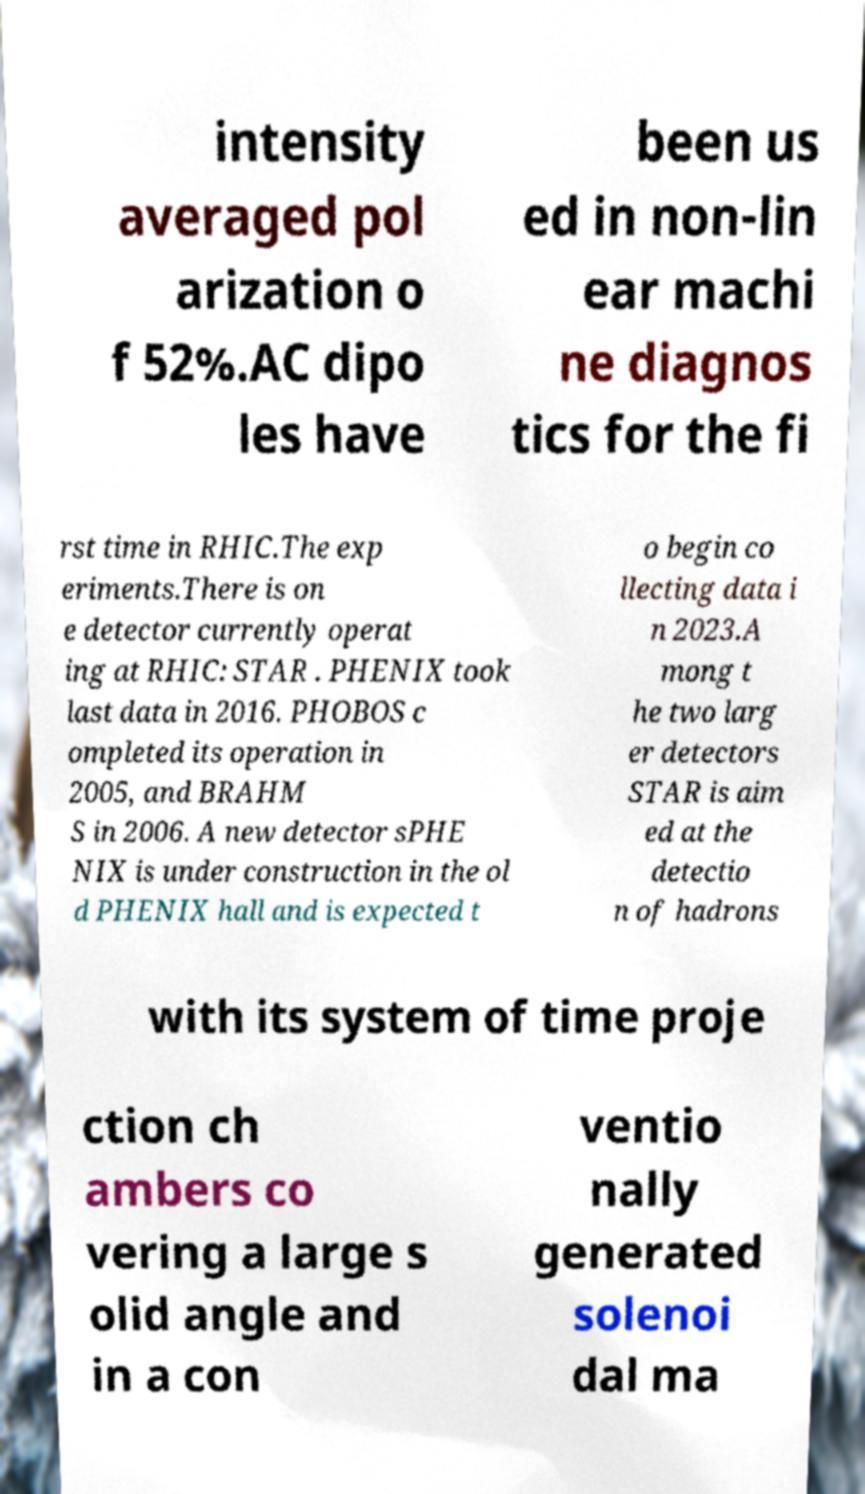Please read and relay the text visible in this image. What does it say? intensity averaged pol arization o f 52%.AC dipo les have been us ed in non-lin ear machi ne diagnos tics for the fi rst time in RHIC.The exp eriments.There is on e detector currently operat ing at RHIC: STAR . PHENIX took last data in 2016. PHOBOS c ompleted its operation in 2005, and BRAHM S in 2006. A new detector sPHE NIX is under construction in the ol d PHENIX hall and is expected t o begin co llecting data i n 2023.A mong t he two larg er detectors STAR is aim ed at the detectio n of hadrons with its system of time proje ction ch ambers co vering a large s olid angle and in a con ventio nally generated solenoi dal ma 